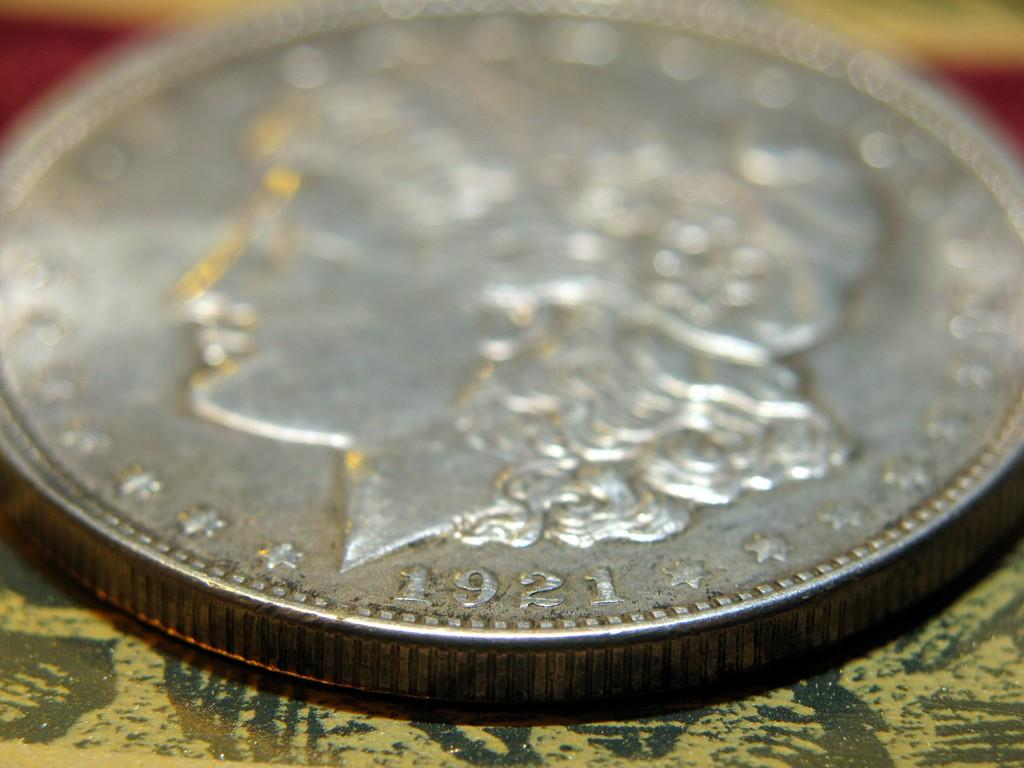Provide a one-sentence caption for the provided image. A coin has the year 1921 below the head. 